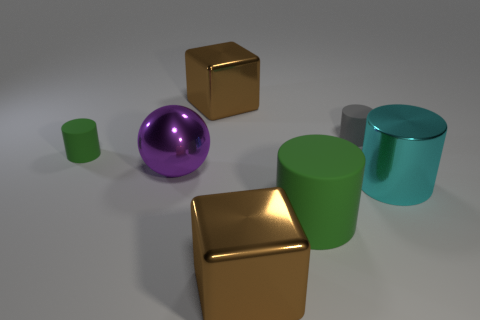Subtract all big shiny cylinders. How many cylinders are left? 3 Subtract all gray cylinders. How many cylinders are left? 3 Add 2 large brown blocks. How many objects exist? 9 Subtract all cylinders. How many objects are left? 3 Subtract 1 balls. How many balls are left? 0 Subtract all red spheres. Subtract all red cylinders. How many spheres are left? 1 Subtract all brown balls. How many gray cylinders are left? 1 Add 7 large brown matte cubes. How many large brown matte cubes exist? 7 Subtract 0 red cylinders. How many objects are left? 7 Subtract all purple metallic balls. Subtract all big matte spheres. How many objects are left? 6 